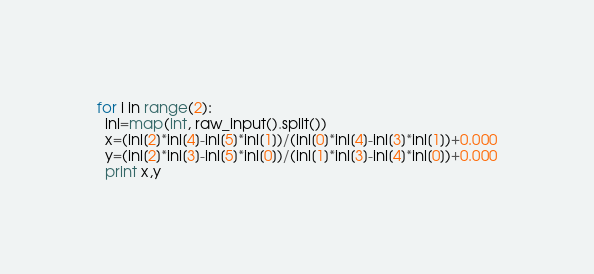<code> <loc_0><loc_0><loc_500><loc_500><_Python_>for i in range(2):
  inl=map(int, raw_input().split())
  x=(inl[2]*inl[4]-inl[5]*inl[1])/(inl[0]*inl[4]-inl[3]*inl[1])+0.000
  y=(inl[2]*inl[3]-inl[5]*inl[0])/(inl[1]*inl[3]-inl[4]*inl[0])+0.000
  print x,y</code> 